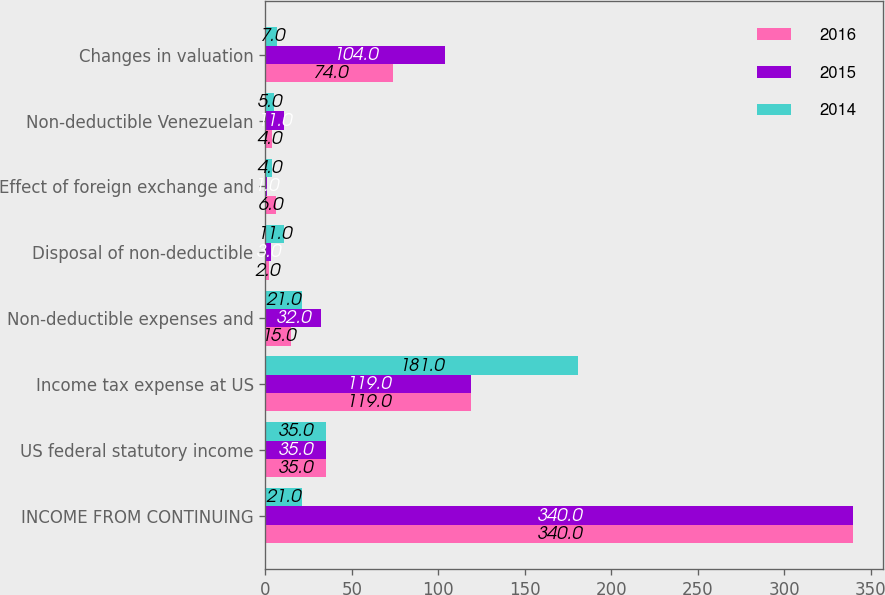Convert chart to OTSL. <chart><loc_0><loc_0><loc_500><loc_500><stacked_bar_chart><ecel><fcel>INCOME FROM CONTINUING<fcel>US federal statutory income<fcel>Income tax expense at US<fcel>Non-deductible expenses and<fcel>Disposal of non-deductible<fcel>Effect of foreign exchange and<fcel>Non-deductible Venezuelan<fcel>Changes in valuation<nl><fcel>2016<fcel>340<fcel>35<fcel>119<fcel>15<fcel>2<fcel>6<fcel>4<fcel>74<nl><fcel>2015<fcel>340<fcel>35<fcel>119<fcel>32<fcel>3<fcel>1<fcel>11<fcel>104<nl><fcel>2014<fcel>21<fcel>35<fcel>181<fcel>21<fcel>11<fcel>4<fcel>5<fcel>7<nl></chart> 